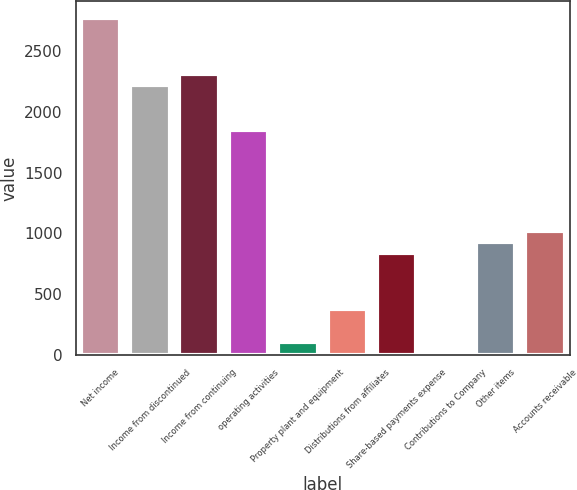Convert chart to OTSL. <chart><loc_0><loc_0><loc_500><loc_500><bar_chart><fcel>Net income<fcel>Income from discontinued<fcel>Income from continuing<fcel>operating activities<fcel>Property plant and equipment<fcel>Distributions from affiliates<fcel>Share-based payments expense<fcel>Contributions to Company<fcel>Other items<fcel>Accounts receivable<nl><fcel>2775.2<fcel>2221.82<fcel>2314.05<fcel>1852.9<fcel>100.53<fcel>377.22<fcel>838.37<fcel>8.3<fcel>930.6<fcel>1022.83<nl></chart> 